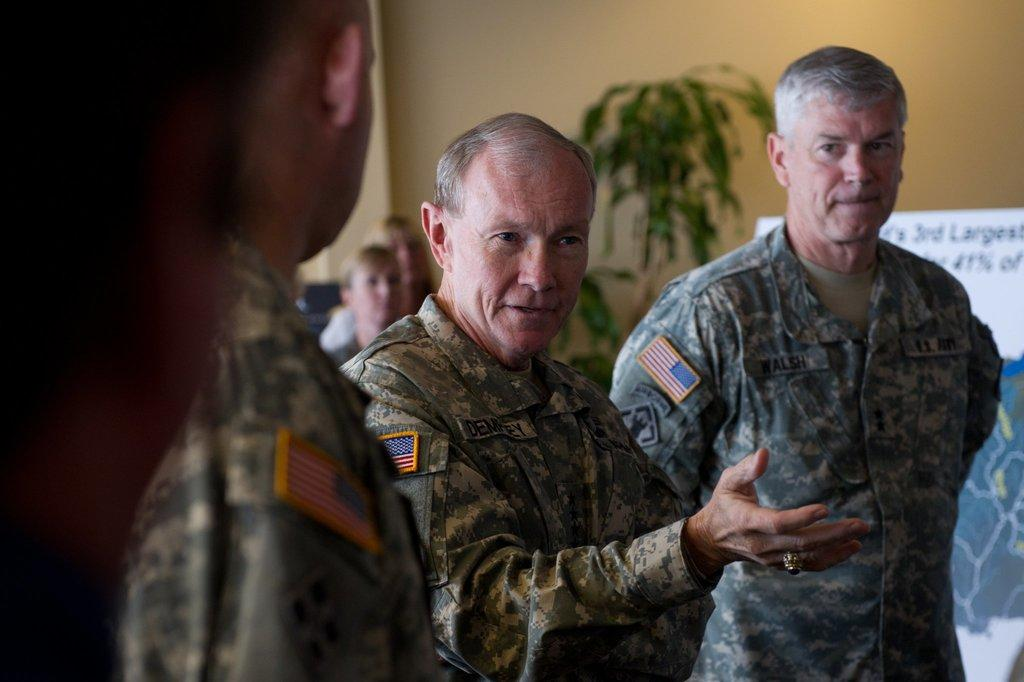How many people are in the image? There is a group of persons in the image. What are the people wearing? The persons are wearing camouflage dress. What are the people doing in the image? The persons are standing and discussing. What can be seen in the background of the image? There is a board, a plant, and a wall in the background of the image. What type of eye is visible on the board in the image? There is no eye present on the board in the image. What kind of vessel is being used by the persons in the image? The persons in the image are not using any vessels; they are standing and discussing. 